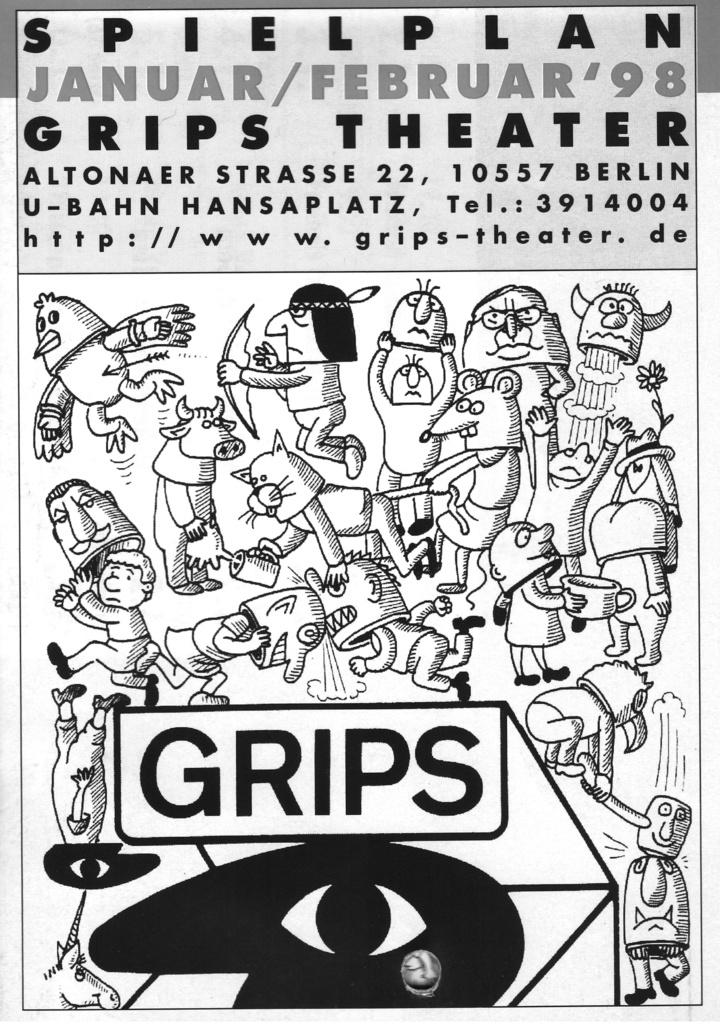What type of visual is the image? The image appears to be a poster. What can be found at the top of the poster? There is text at the top of the poster. What is depicted in the foreground of the image? Cartoons are present in the foreground of the image. How many seeds are visible in the image? There are no seeds present in the image. Can you hear the cartoons in the image? The image is visual, so there is no sound or hearing involved. 